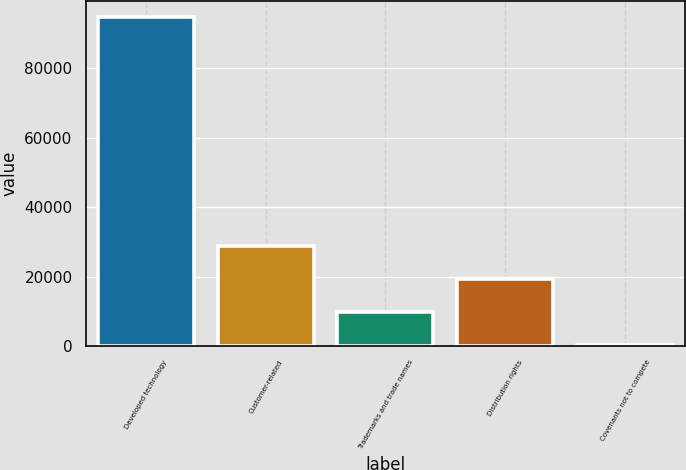Convert chart to OTSL. <chart><loc_0><loc_0><loc_500><loc_500><bar_chart><fcel>Developed technology<fcel>Customer-related<fcel>Trademarks and trade names<fcel>Distribution rights<fcel>Covenants not to compete<nl><fcel>94681<fcel>28684.3<fcel>9828.1<fcel>19256.2<fcel>400<nl></chart> 